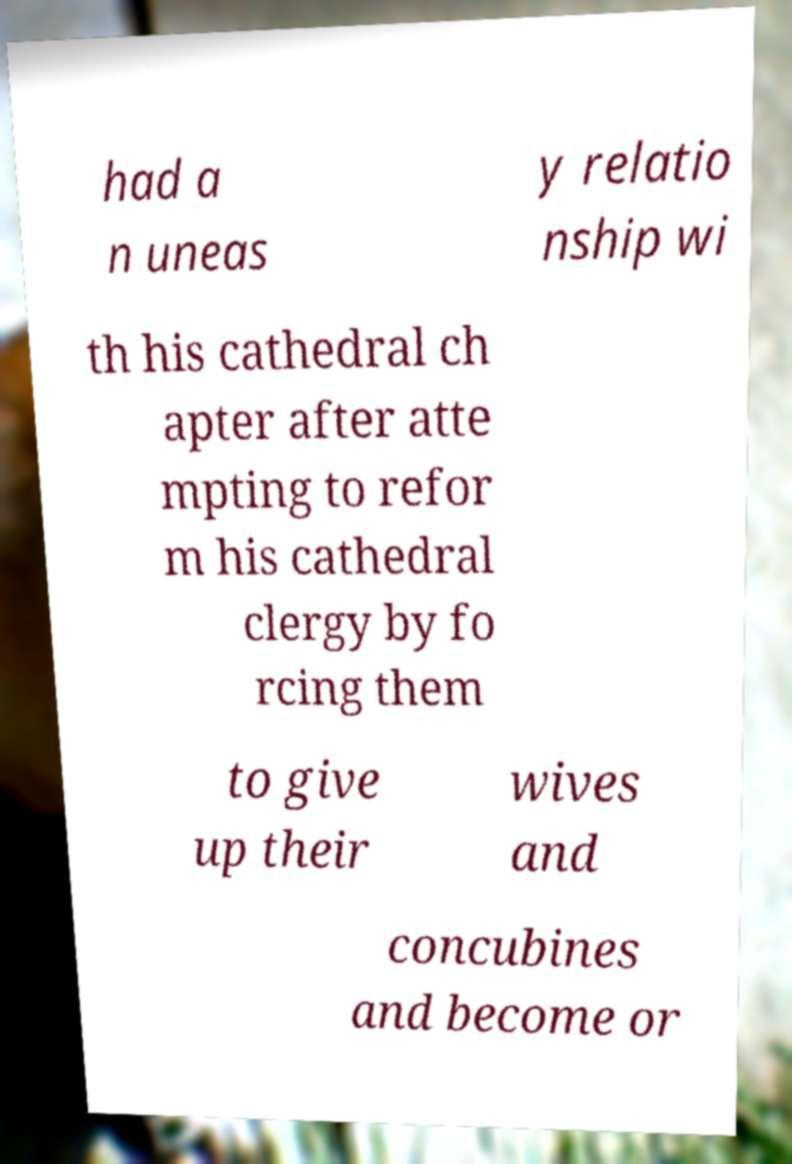What messages or text are displayed in this image? I need them in a readable, typed format. had a n uneas y relatio nship wi th his cathedral ch apter after atte mpting to refor m his cathedral clergy by fo rcing them to give up their wives and concubines and become or 